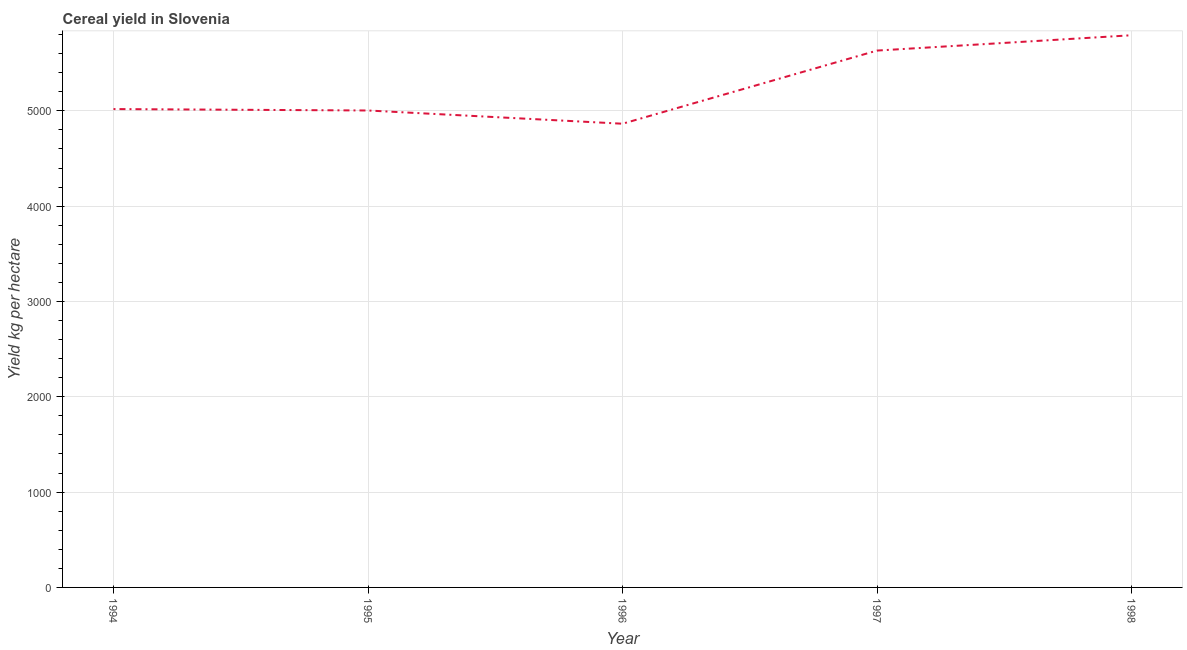What is the cereal yield in 1995?
Keep it short and to the point. 5003.65. Across all years, what is the maximum cereal yield?
Your response must be concise. 5793.06. Across all years, what is the minimum cereal yield?
Offer a very short reply. 4864.85. In which year was the cereal yield maximum?
Your answer should be very brief. 1998. What is the sum of the cereal yield?
Provide a succinct answer. 2.63e+04. What is the difference between the cereal yield in 1996 and 1998?
Give a very brief answer. -928.21. What is the average cereal yield per year?
Offer a very short reply. 5262.51. What is the median cereal yield?
Provide a short and direct response. 5018.67. Do a majority of the years between 1996 and 1994 (inclusive) have cereal yield greater than 2200 kg per hectare?
Provide a short and direct response. No. What is the ratio of the cereal yield in 1996 to that in 1997?
Provide a succinct answer. 0.86. Is the cereal yield in 1994 less than that in 1998?
Ensure brevity in your answer.  Yes. Is the difference between the cereal yield in 1995 and 1996 greater than the difference between any two years?
Your response must be concise. No. What is the difference between the highest and the second highest cereal yield?
Your answer should be very brief. 160.74. Is the sum of the cereal yield in 1995 and 1998 greater than the maximum cereal yield across all years?
Offer a very short reply. Yes. What is the difference between the highest and the lowest cereal yield?
Give a very brief answer. 928.21. In how many years, is the cereal yield greater than the average cereal yield taken over all years?
Your response must be concise. 2. How many years are there in the graph?
Provide a succinct answer. 5. What is the title of the graph?
Give a very brief answer. Cereal yield in Slovenia. What is the label or title of the X-axis?
Keep it short and to the point. Year. What is the label or title of the Y-axis?
Your response must be concise. Yield kg per hectare. What is the Yield kg per hectare in 1994?
Keep it short and to the point. 5018.67. What is the Yield kg per hectare of 1995?
Ensure brevity in your answer.  5003.65. What is the Yield kg per hectare in 1996?
Provide a short and direct response. 4864.85. What is the Yield kg per hectare of 1997?
Offer a very short reply. 5632.32. What is the Yield kg per hectare of 1998?
Your response must be concise. 5793.06. What is the difference between the Yield kg per hectare in 1994 and 1995?
Make the answer very short. 15.02. What is the difference between the Yield kg per hectare in 1994 and 1996?
Keep it short and to the point. 153.82. What is the difference between the Yield kg per hectare in 1994 and 1997?
Provide a short and direct response. -613.65. What is the difference between the Yield kg per hectare in 1994 and 1998?
Make the answer very short. -774.39. What is the difference between the Yield kg per hectare in 1995 and 1996?
Provide a short and direct response. 138.8. What is the difference between the Yield kg per hectare in 1995 and 1997?
Provide a short and direct response. -628.67. What is the difference between the Yield kg per hectare in 1995 and 1998?
Keep it short and to the point. -789.41. What is the difference between the Yield kg per hectare in 1996 and 1997?
Ensure brevity in your answer.  -767.47. What is the difference between the Yield kg per hectare in 1996 and 1998?
Provide a short and direct response. -928.21. What is the difference between the Yield kg per hectare in 1997 and 1998?
Offer a very short reply. -160.74. What is the ratio of the Yield kg per hectare in 1994 to that in 1996?
Your answer should be very brief. 1.03. What is the ratio of the Yield kg per hectare in 1994 to that in 1997?
Ensure brevity in your answer.  0.89. What is the ratio of the Yield kg per hectare in 1994 to that in 1998?
Provide a short and direct response. 0.87. What is the ratio of the Yield kg per hectare in 1995 to that in 1996?
Offer a very short reply. 1.03. What is the ratio of the Yield kg per hectare in 1995 to that in 1997?
Give a very brief answer. 0.89. What is the ratio of the Yield kg per hectare in 1995 to that in 1998?
Give a very brief answer. 0.86. What is the ratio of the Yield kg per hectare in 1996 to that in 1997?
Keep it short and to the point. 0.86. What is the ratio of the Yield kg per hectare in 1996 to that in 1998?
Give a very brief answer. 0.84. 